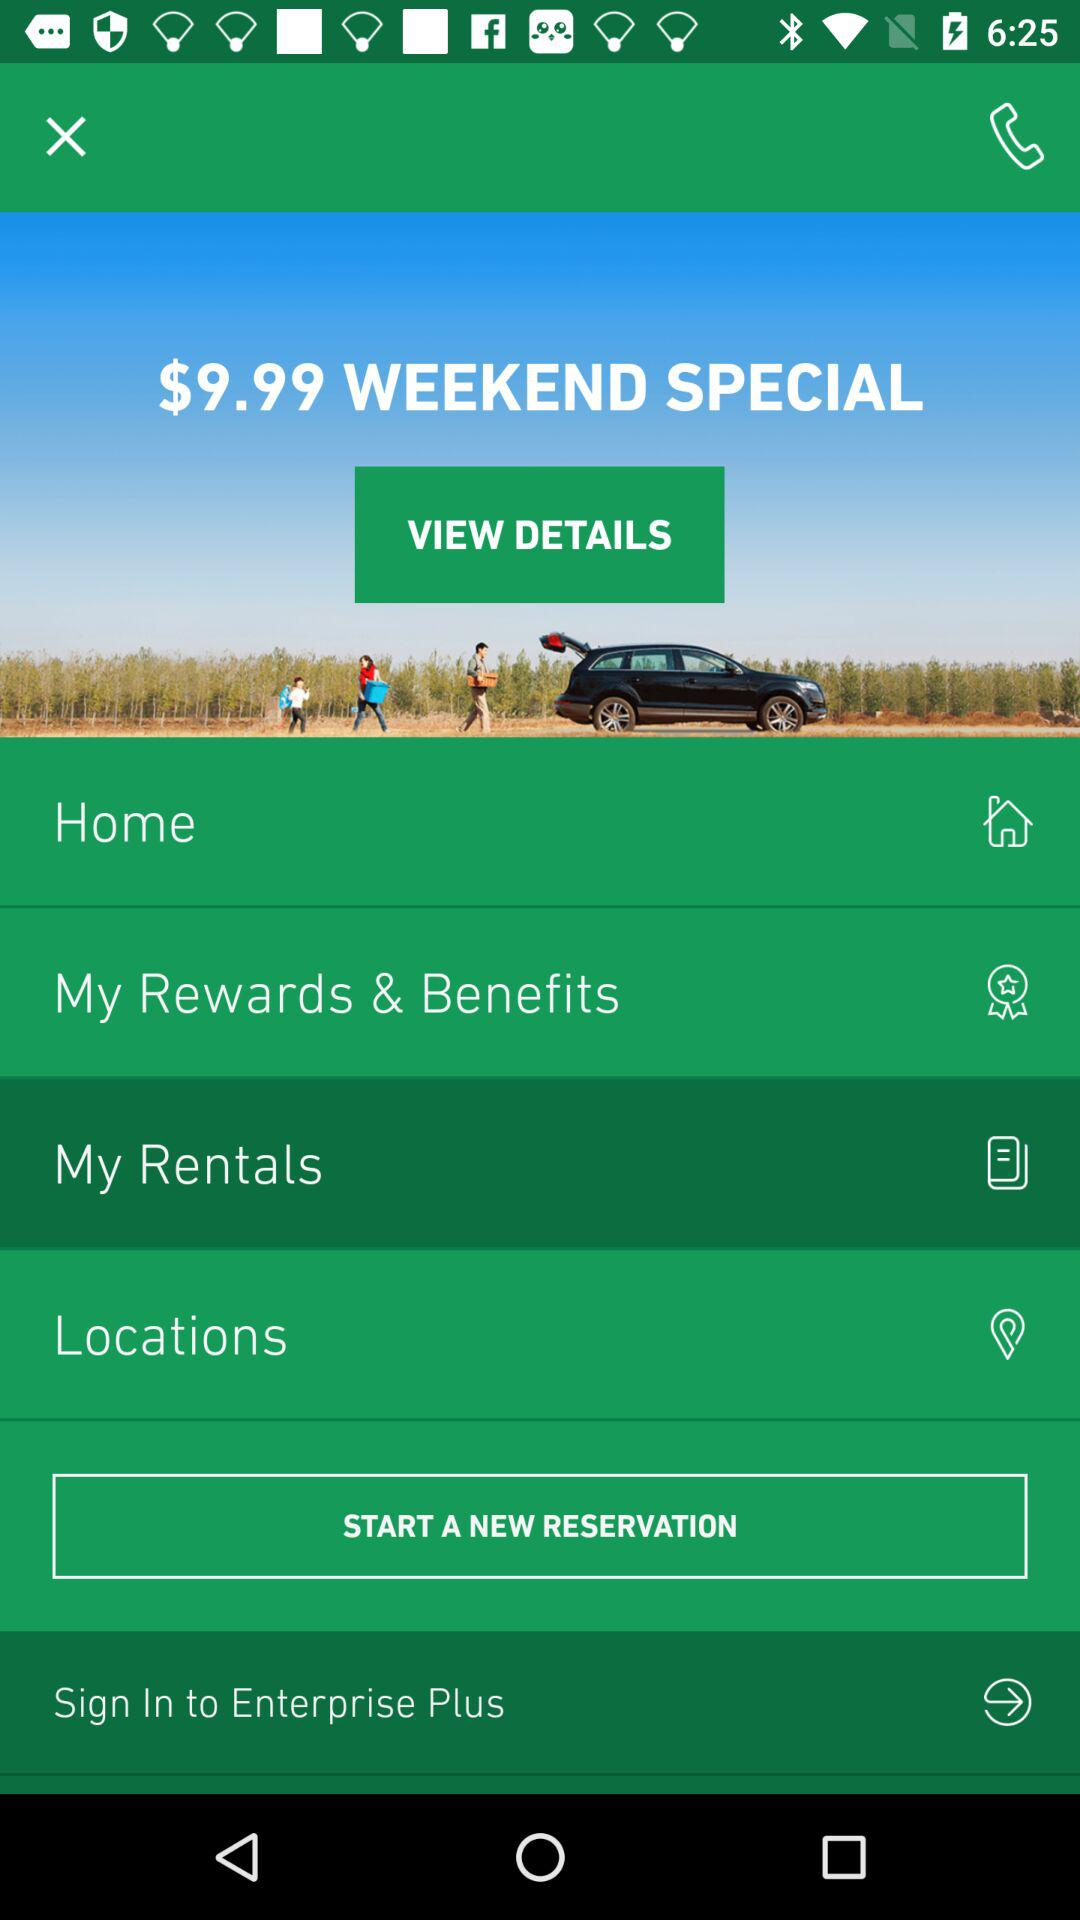What’s the currency for the prices? The currency for the prices is "$". 